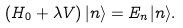<formula> <loc_0><loc_0><loc_500><loc_500>\left ( H _ { 0 } + \lambda V \right ) | n \rangle = E _ { n } | n \rangle .</formula> 